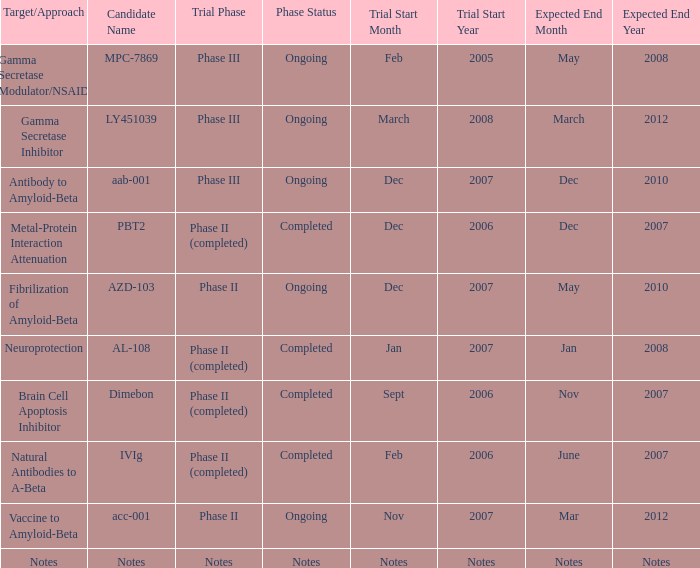For a "vaccine to amyloid-beta" target/approach, what is the designated candidate name? Acc-001. 